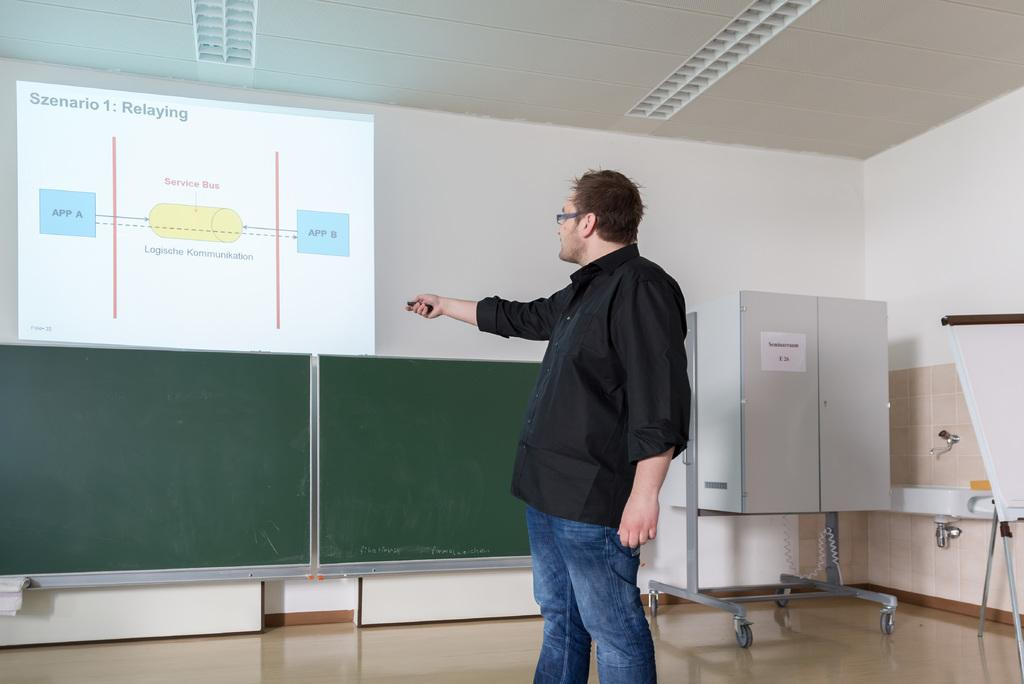<image>
Create a compact narrative representing the image presented. A man is showing a powerpoint presentation about Relaying. 